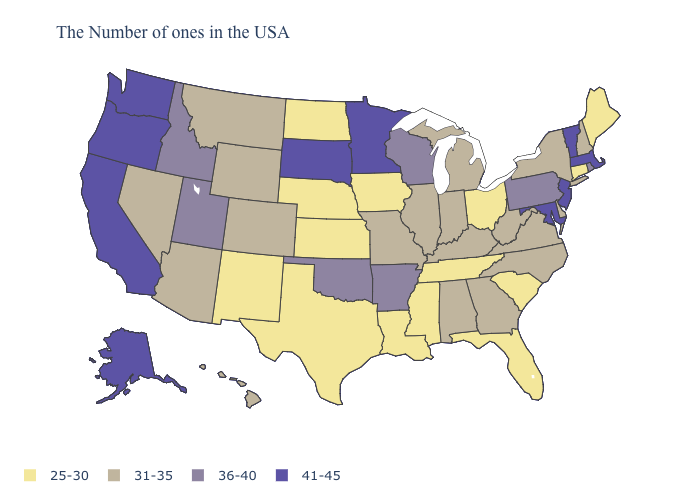Name the states that have a value in the range 25-30?
Keep it brief. Maine, Connecticut, South Carolina, Ohio, Florida, Tennessee, Mississippi, Louisiana, Iowa, Kansas, Nebraska, Texas, North Dakota, New Mexico. What is the value of Tennessee?
Write a very short answer. 25-30. Does the map have missing data?
Keep it brief. No. What is the value of Alabama?
Write a very short answer. 31-35. Name the states that have a value in the range 41-45?
Answer briefly. Massachusetts, Vermont, New Jersey, Maryland, Minnesota, South Dakota, California, Washington, Oregon, Alaska. Name the states that have a value in the range 36-40?
Answer briefly. Rhode Island, Pennsylvania, Wisconsin, Arkansas, Oklahoma, Utah, Idaho. Among the states that border New Mexico , does Texas have the lowest value?
Answer briefly. Yes. Name the states that have a value in the range 41-45?
Concise answer only. Massachusetts, Vermont, New Jersey, Maryland, Minnesota, South Dakota, California, Washington, Oregon, Alaska. Name the states that have a value in the range 25-30?
Short answer required. Maine, Connecticut, South Carolina, Ohio, Florida, Tennessee, Mississippi, Louisiana, Iowa, Kansas, Nebraska, Texas, North Dakota, New Mexico. What is the value of Kansas?
Write a very short answer. 25-30. Name the states that have a value in the range 31-35?
Be succinct. New Hampshire, New York, Delaware, Virginia, North Carolina, West Virginia, Georgia, Michigan, Kentucky, Indiana, Alabama, Illinois, Missouri, Wyoming, Colorado, Montana, Arizona, Nevada, Hawaii. What is the value of Kansas?
Keep it brief. 25-30. Is the legend a continuous bar?
Be succinct. No. Does the map have missing data?
Concise answer only. No. Name the states that have a value in the range 25-30?
Concise answer only. Maine, Connecticut, South Carolina, Ohio, Florida, Tennessee, Mississippi, Louisiana, Iowa, Kansas, Nebraska, Texas, North Dakota, New Mexico. 